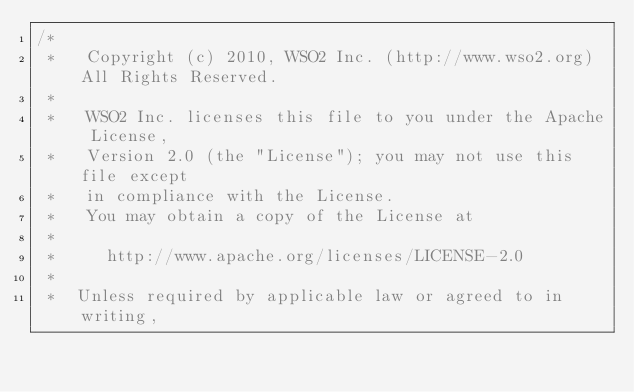<code> <loc_0><loc_0><loc_500><loc_500><_Java_>/*
 *   Copyright (c) 2010, WSO2 Inc. (http://www.wso2.org) All Rights Reserved.
 *
 *   WSO2 Inc. licenses this file to you under the Apache License,
 *   Version 2.0 (the "License"); you may not use this file except
 *   in compliance with the License.
 *   You may obtain a copy of the License at
 *
 *     http://www.apache.org/licenses/LICENSE-2.0
 *
 *  Unless required by applicable law or agreed to in writing,</code> 